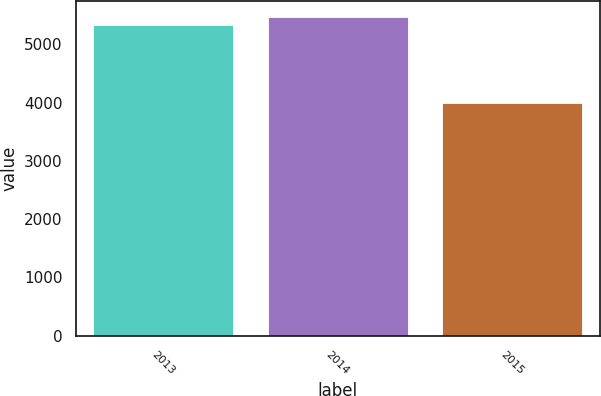<chart> <loc_0><loc_0><loc_500><loc_500><bar_chart><fcel>2013<fcel>2014<fcel>2015<nl><fcel>5330<fcel>5463.3<fcel>3997<nl></chart> 